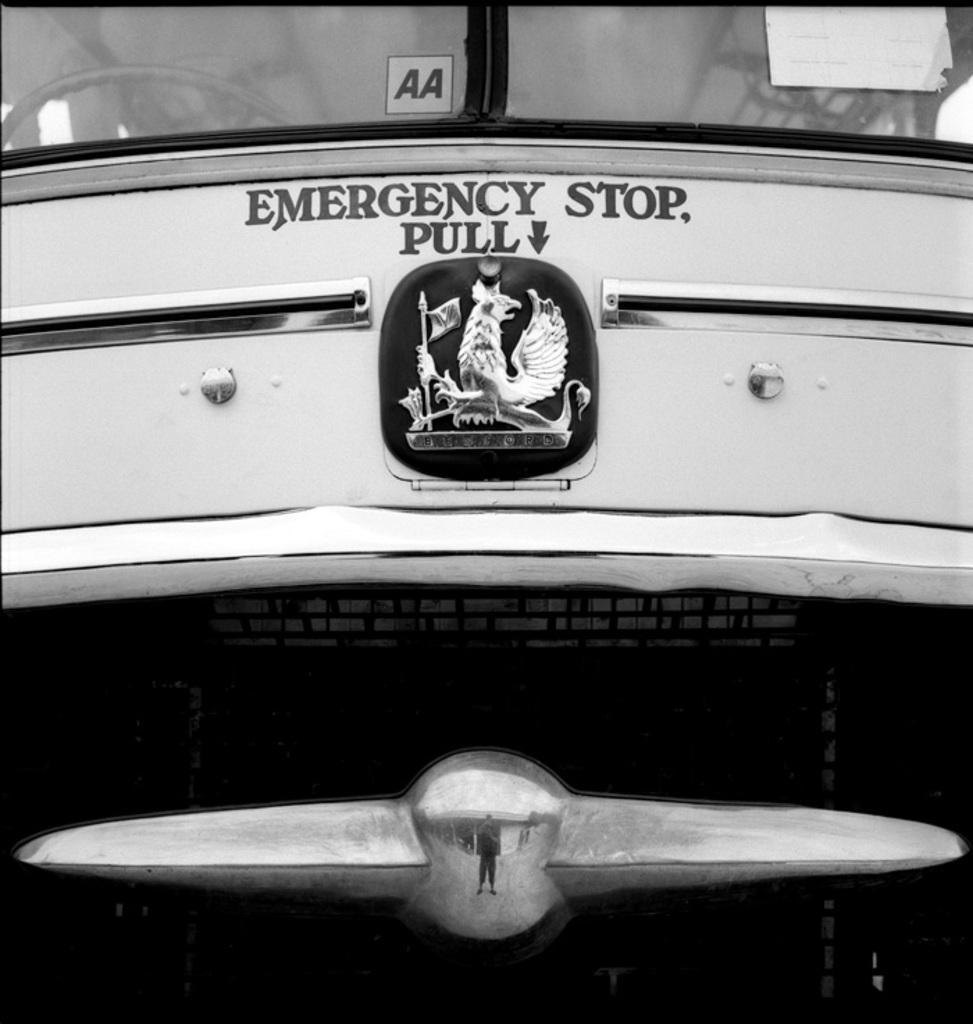<image>
Summarize the visual content of the image. The front of a buy has an emergency stop lever marked. 